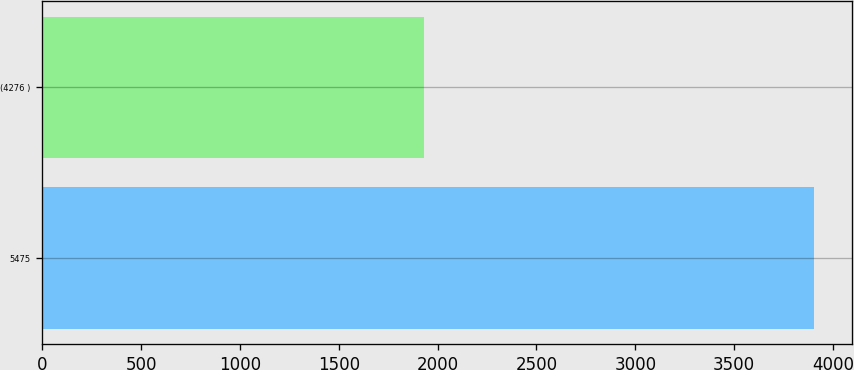<chart> <loc_0><loc_0><loc_500><loc_500><bar_chart><fcel>5475<fcel>(4276 )<nl><fcel>3903<fcel>1930<nl></chart> 